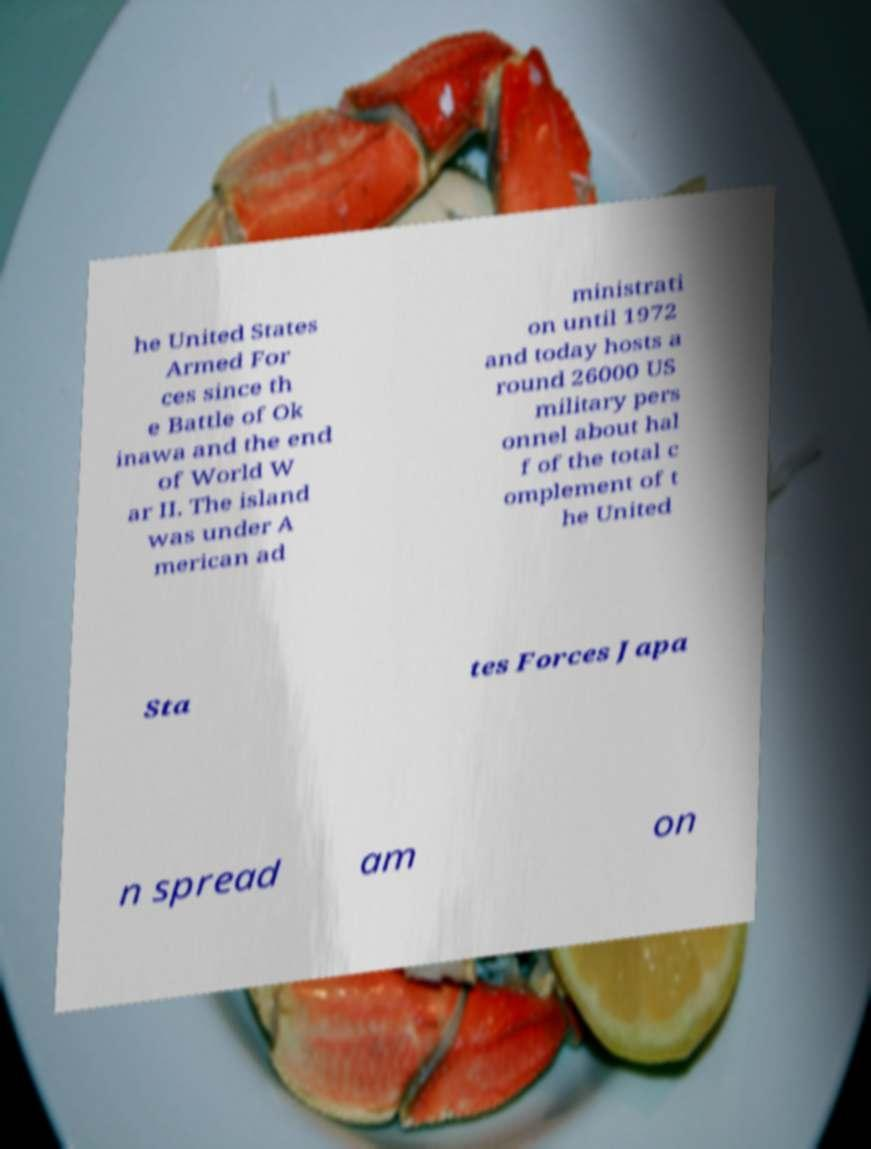Please identify and transcribe the text found in this image. he United States Armed For ces since th e Battle of Ok inawa and the end of World W ar II. The island was under A merican ad ministrati on until 1972 and today hosts a round 26000 US military pers onnel about hal f of the total c omplement of t he United Sta tes Forces Japa n spread am on 